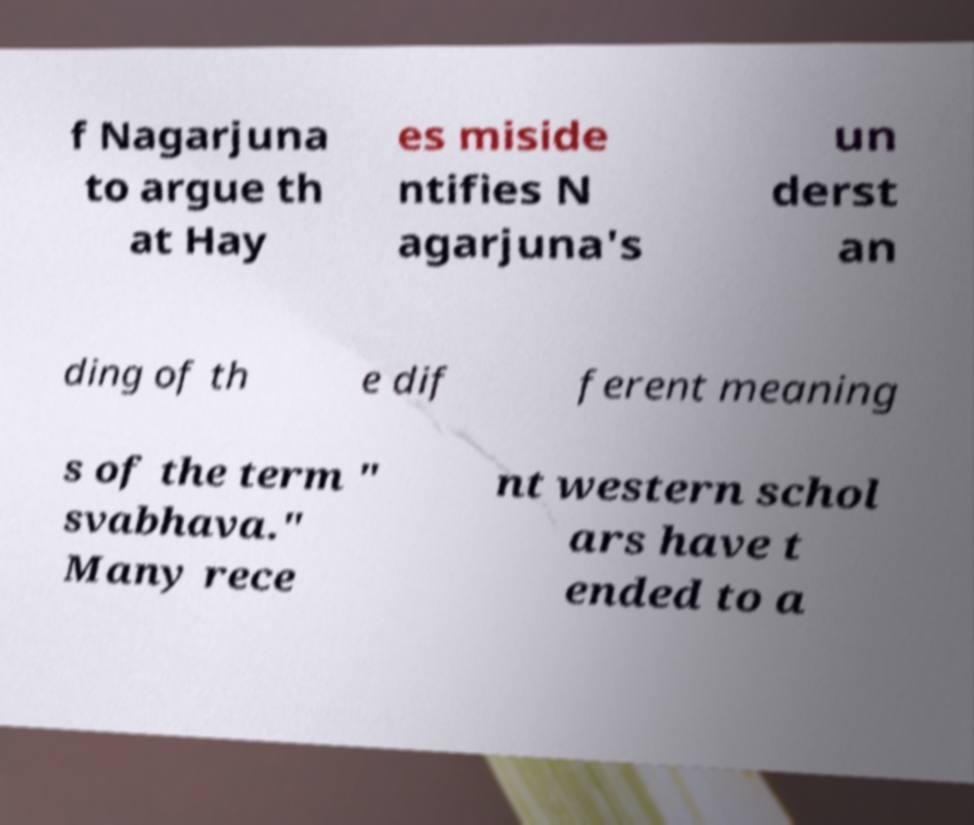Could you extract and type out the text from this image? f Nagarjuna to argue th at Hay es miside ntifies N agarjuna's un derst an ding of th e dif ferent meaning s of the term " svabhava." Many rece nt western schol ars have t ended to a 